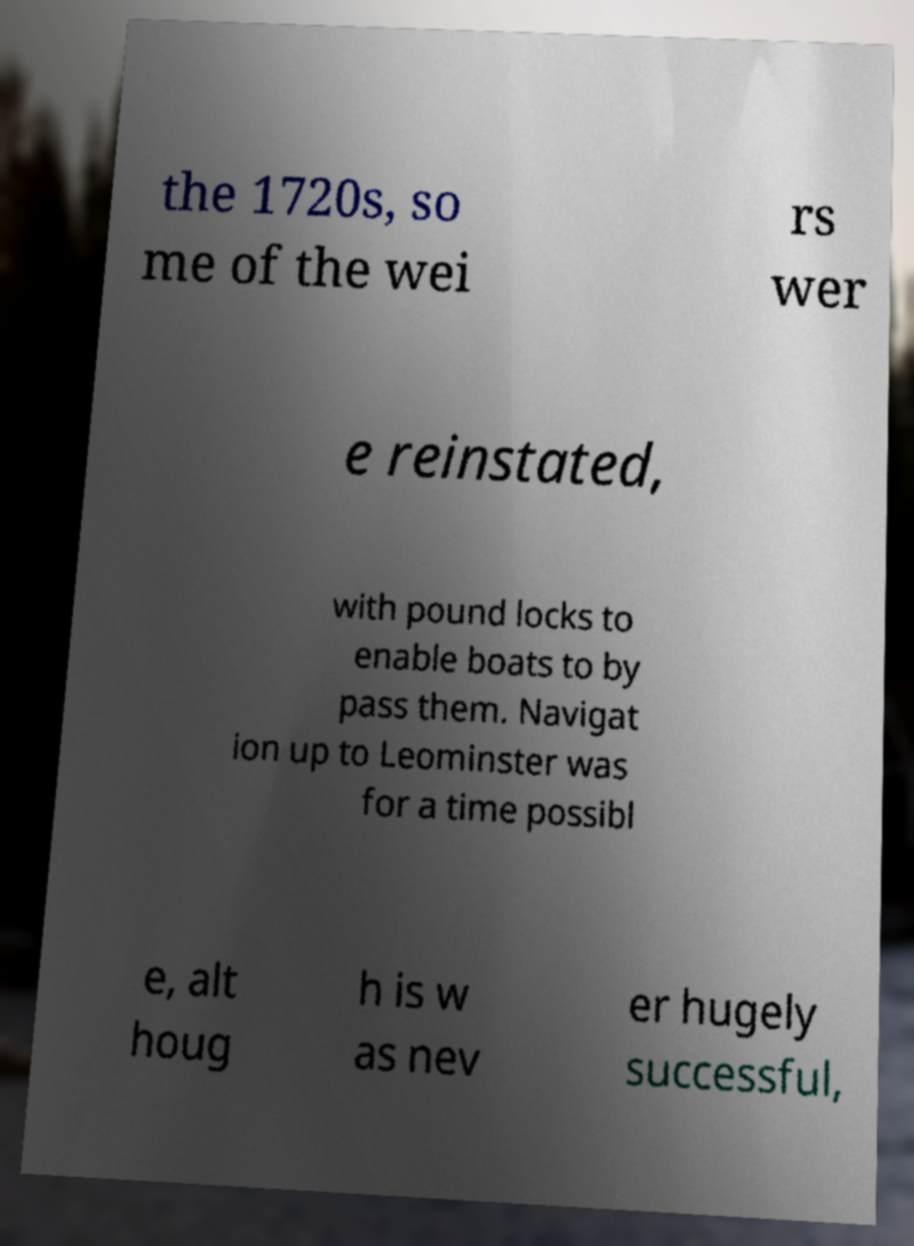There's text embedded in this image that I need extracted. Can you transcribe it verbatim? the 1720s, so me of the wei rs wer e reinstated, with pound locks to enable boats to by pass them. Navigat ion up to Leominster was for a time possibl e, alt houg h is w as nev er hugely successful, 